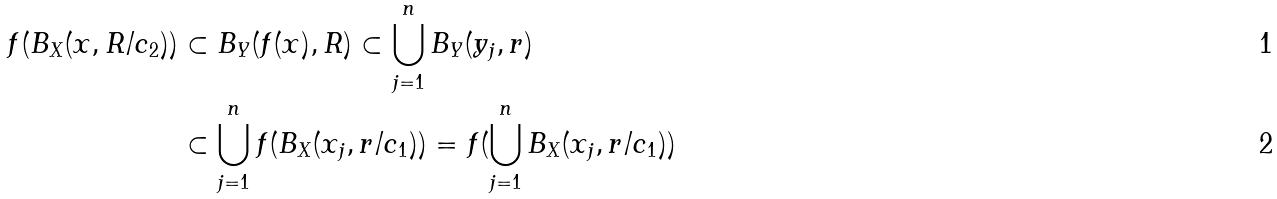<formula> <loc_0><loc_0><loc_500><loc_500>f ( B _ { X } ( x , R / c _ { 2 } ) ) & \subset B _ { Y } ( f ( x ) , R ) \subset \bigcup _ { j = 1 } ^ { n } B _ { Y } ( y _ { j } , r ) \\ & \subset \bigcup _ { j = 1 } ^ { n } f ( B _ { X } ( x _ { j } , r / c _ { 1 } ) ) = f ( \bigcup _ { j = 1 } ^ { n } B _ { X } ( x _ { j } , r / c _ { 1 } ) )</formula> 